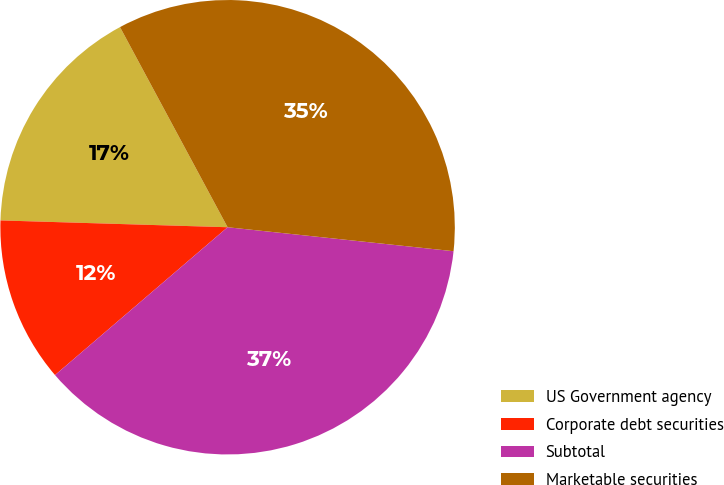Convert chart. <chart><loc_0><loc_0><loc_500><loc_500><pie_chart><fcel>US Government agency<fcel>Corporate debt securities<fcel>Subtotal<fcel>Marketable securities<nl><fcel>16.67%<fcel>11.75%<fcel>37.04%<fcel>34.53%<nl></chart> 